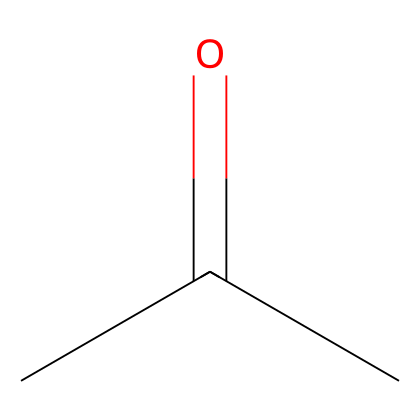What is the molecular formula of acetone? The SMILES representation CC(=O)C indicates that acetone consists of three carbon (C) atoms, six hydrogen (H) atoms, and one oxygen (O) atom, leading to the molecular formula C3H6O.
Answer: C3H6O How many carbon atoms are present in acetone? The SMILES representation shows three carbon atoms: the two 'C' in the chain and one from the carbonyl group (C=O). Therefore, there are three carbon atoms in total.
Answer: 3 What is the main functional group in acetone? The SMILES notation includes a carbonyl (C=O) group, which is characteristic of ketones. Therefore, the main functional group in acetone is the carbonyl group.
Answer: carbonyl What is the hybridization state of the central carbon atom in acetone? The central carbon in acetone forms one double bond with oxygen and two single bonds with other carbons, resulting in sp2 hybridization.
Answer: sp2 Is acetone classified as an aromatic compound? Acetone does not contain a benzene ring or other characteristics of aromatic compounds; it is categorized as a simple ketone. Therefore, it is not an aromatic compound.
Answer: no How many hydrogen atoms are bonded to the terminal carbon in acetone? The terminal carbon atom in acetone is single-bonded to three hydrogen atoms, making a total of three hydrogen atoms attached to that carbon.
Answer: 3 What type of chemical reaction is primarily associated with acetone? Acetone is widely used in reactions such as nucleophilic addition due to its carbonyl group, which can undergo various reactions with nucleophiles.
Answer: nucleophilic addition 